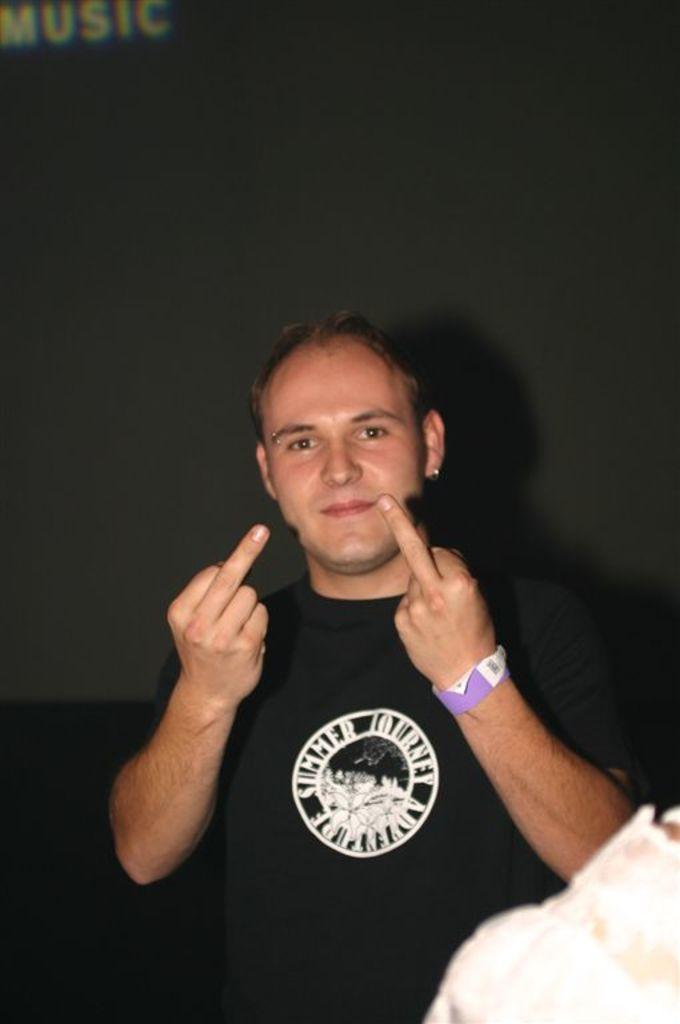Who is the main subject in the image? There is a man in the image. What is the man wearing? The man is wearing a black t-shirt. Where is the man positioned in the image? The man is standing in the front. What is the man's facial expression in the image? The man is smiling. What is the man doing in the image? The man is giving a pose to the camera. What is the color of the background in the image? The background of the image is dark. What type of stamp can be seen on the man's forehead in the image? There is no stamp present on the man's forehead in the image. What sound does the bell make when the man rings it in the image? There is no bell present in the image, so it cannot be rung or heard. 